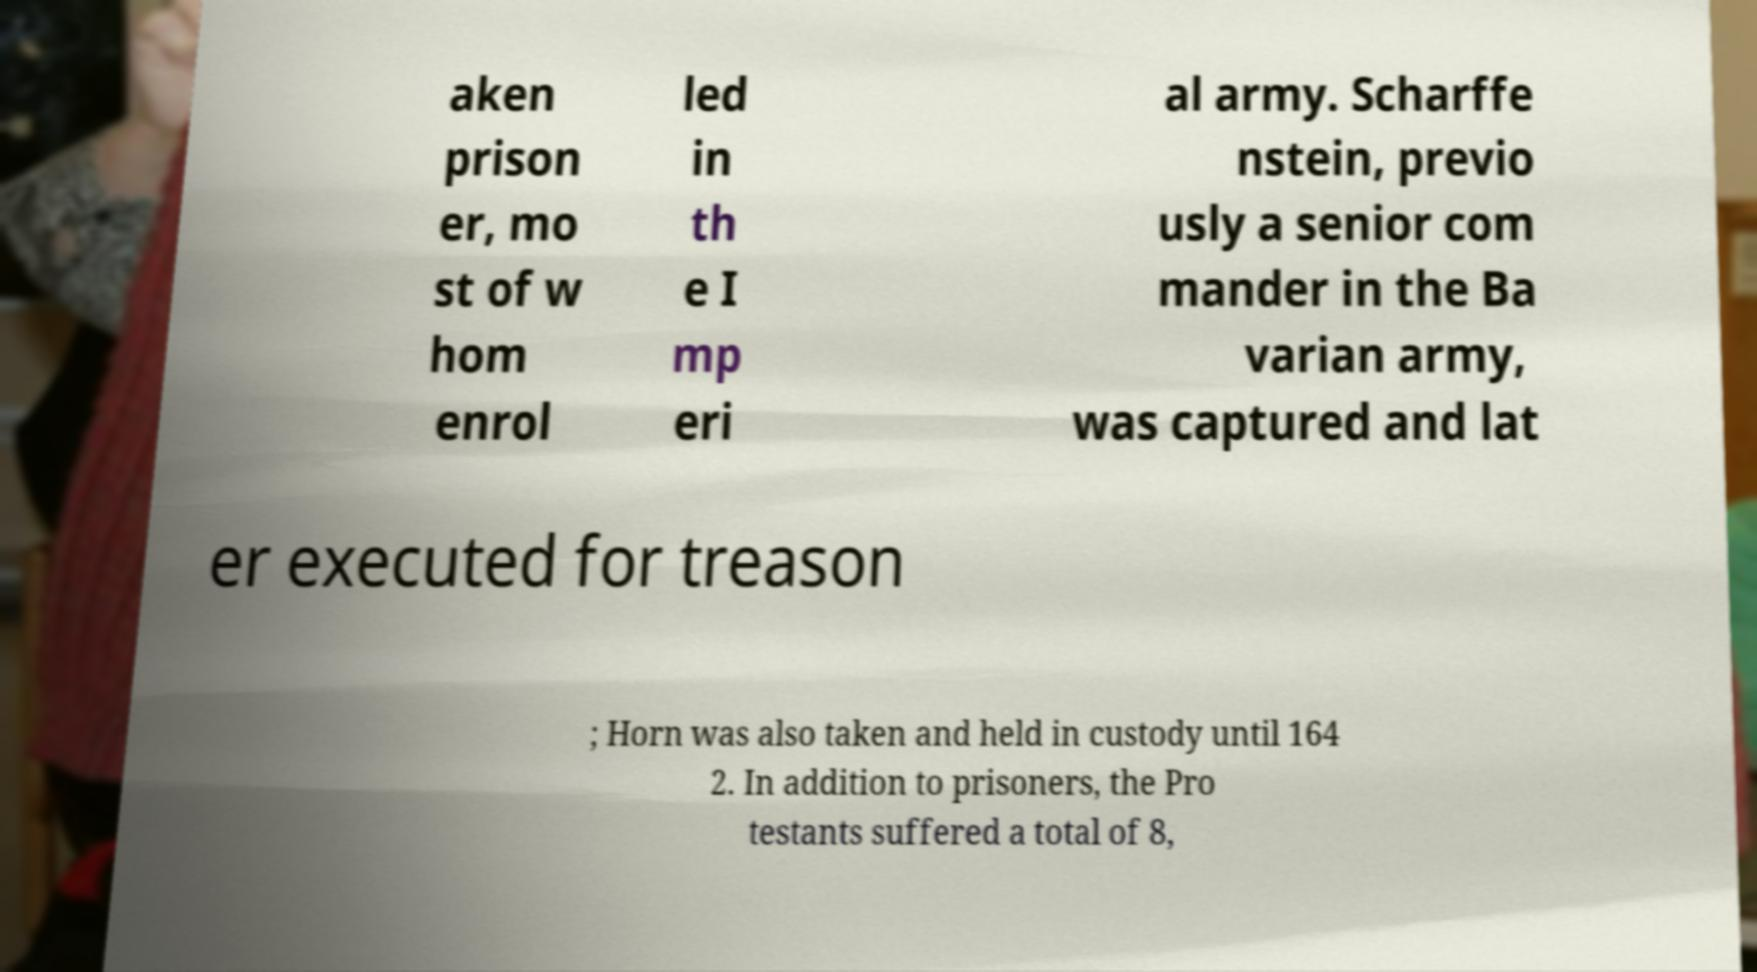There's text embedded in this image that I need extracted. Can you transcribe it verbatim? aken prison er, mo st of w hom enrol led in th e I mp eri al army. Scharffe nstein, previo usly a senior com mander in the Ba varian army, was captured and lat er executed for treason ; Horn was also taken and held in custody until 164 2. In addition to prisoners, the Pro testants suffered a total of 8, 